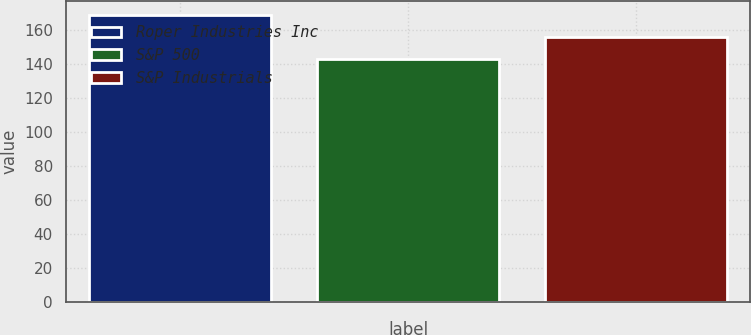<chart> <loc_0><loc_0><loc_500><loc_500><bar_chart><fcel>Roper Industries Inc<fcel>S&P 500<fcel>S&P Industrials<nl><fcel>168.78<fcel>142.69<fcel>156.03<nl></chart> 